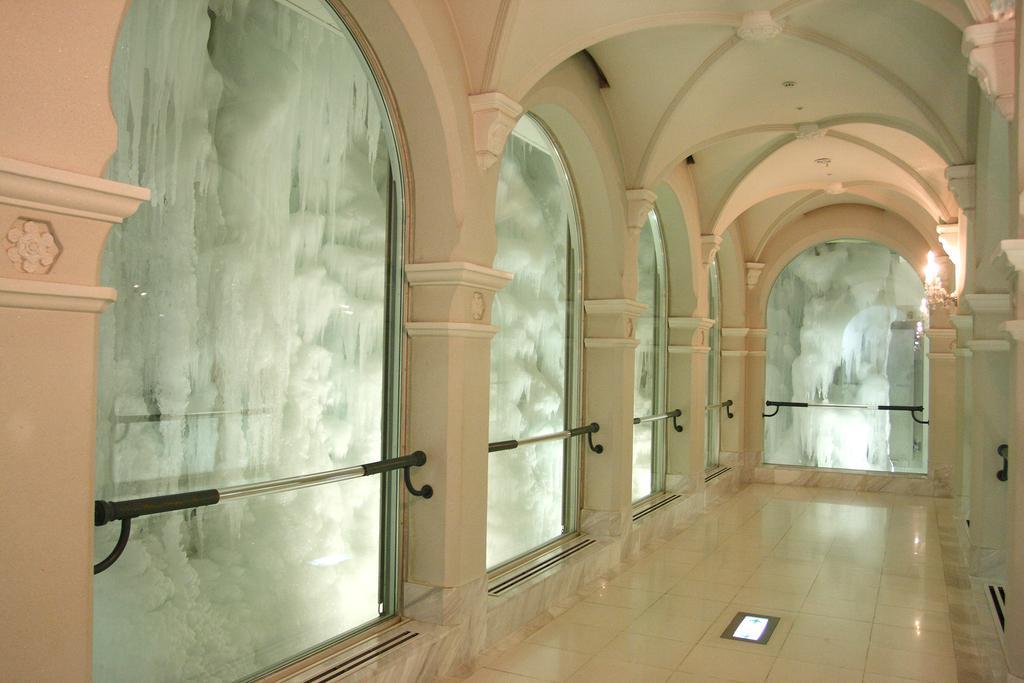In one or two sentences, can you explain what this image depicts? This image is taken from inside the room. In this image we can see there are mirrors to the wall, in front of the mirror there is an iron rod. There is a ice from the outside of the mirror and there are lights to the poles. 